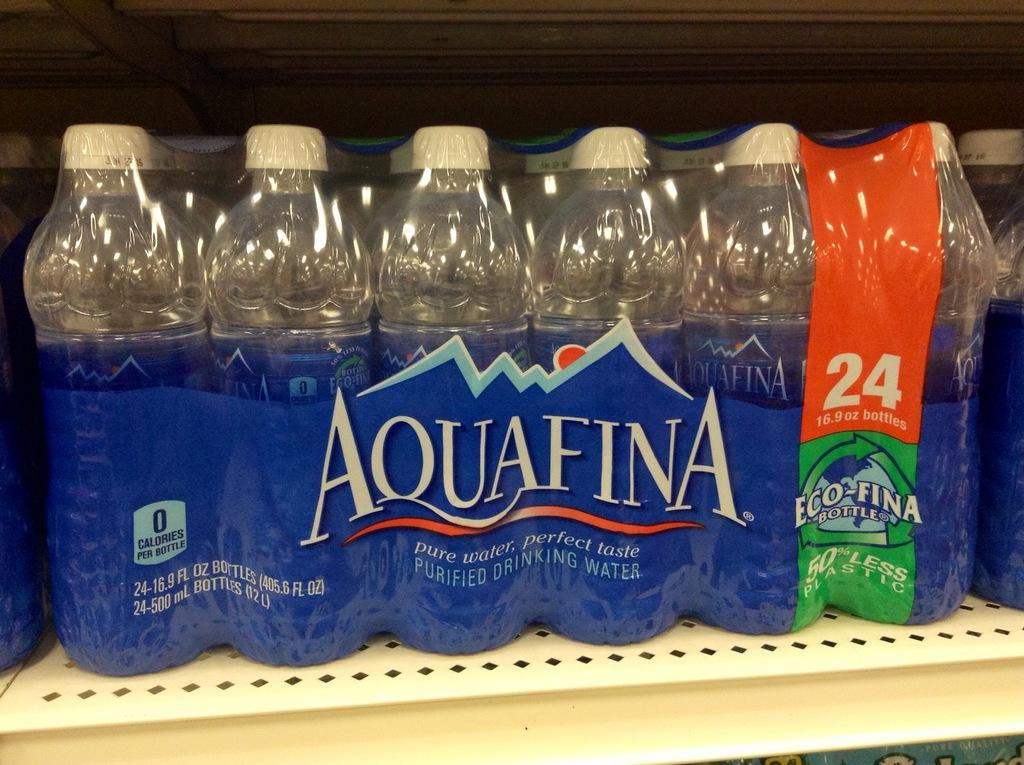Provide a one-sentence caption for the provided image. A pack of 24 bottles of Aquafina water sitting on a store shelf. 